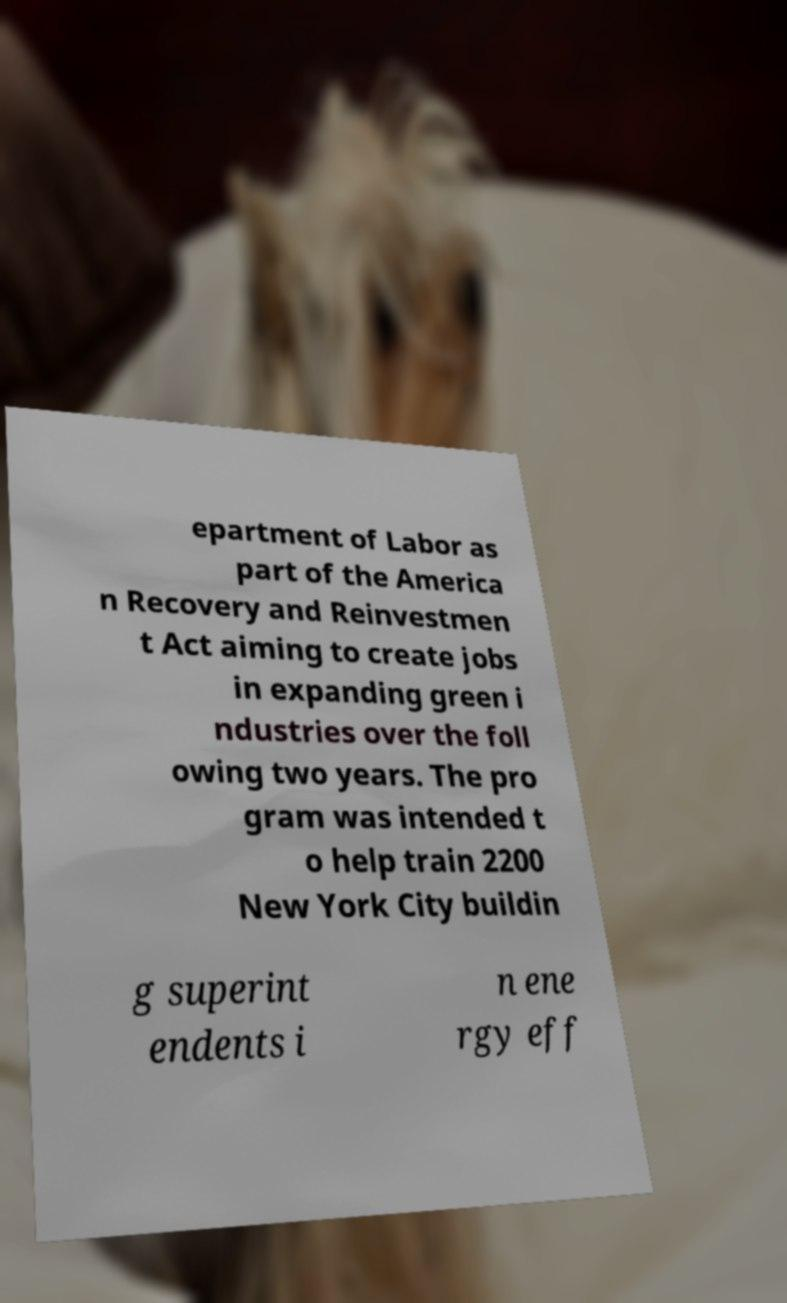For documentation purposes, I need the text within this image transcribed. Could you provide that? epartment of Labor as part of the America n Recovery and Reinvestmen t Act aiming to create jobs in expanding green i ndustries over the foll owing two years. The pro gram was intended t o help train 2200 New York City buildin g superint endents i n ene rgy eff 